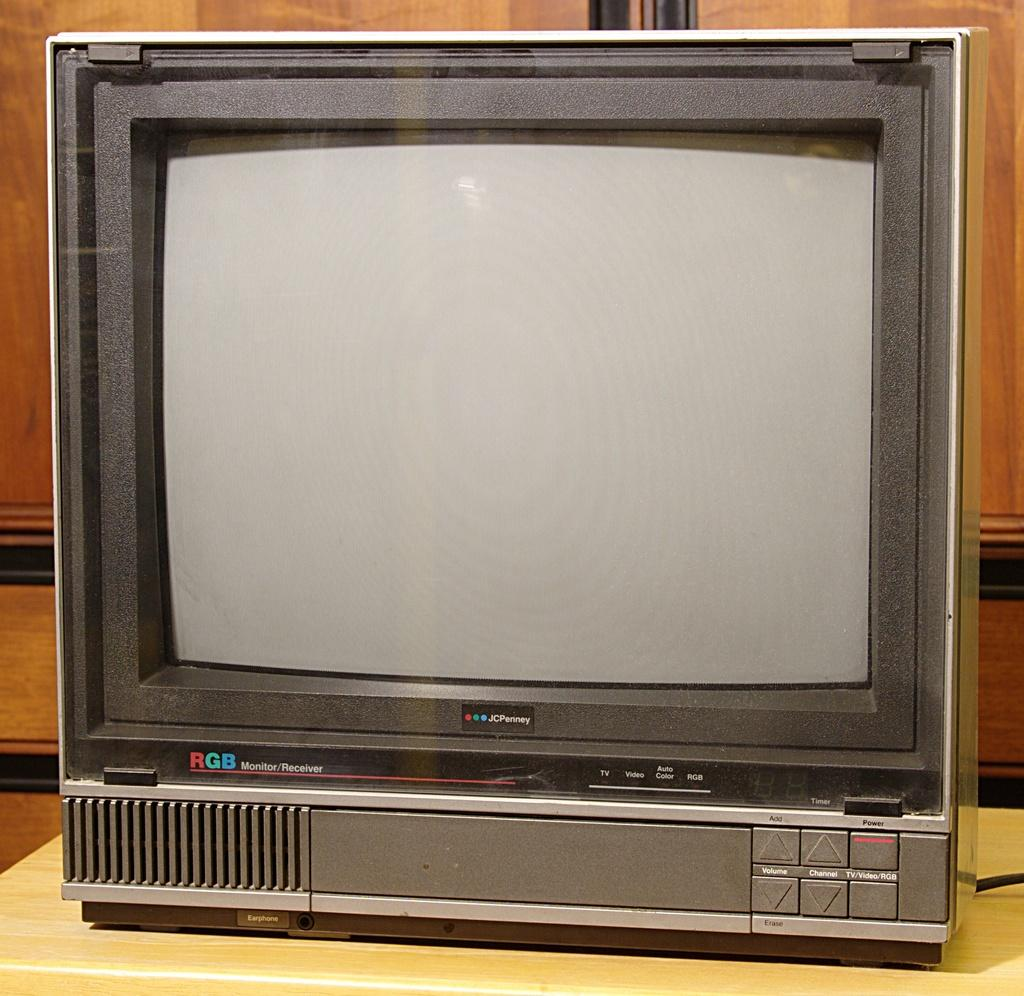Provide a one-sentence caption for the provided image. An old JcPenney RGB Monitor/Receiver sits on a table. 